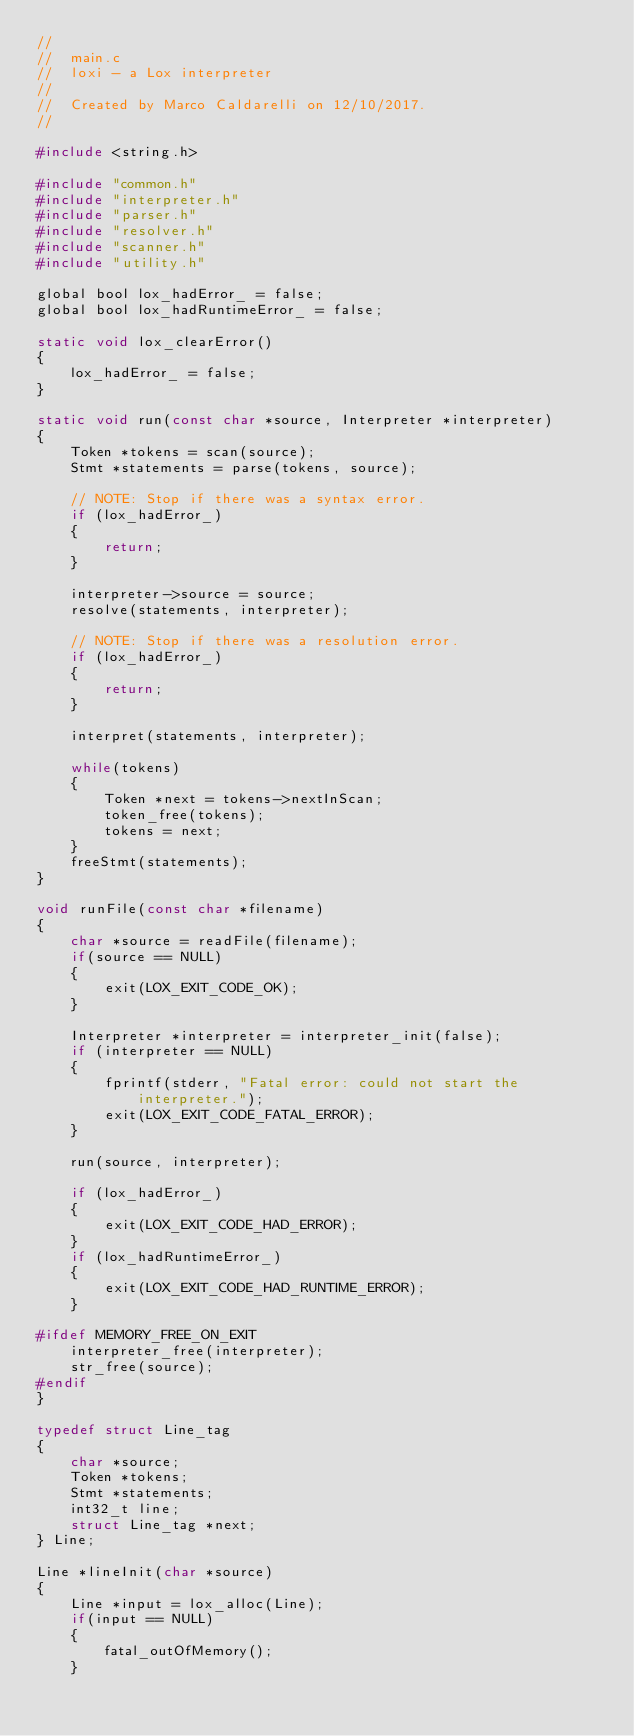<code> <loc_0><loc_0><loc_500><loc_500><_C_>//
//  main.c
//  loxi - a Lox interpreter
//
//  Created by Marco Caldarelli on 12/10/2017.
//

#include <string.h>

#include "common.h"
#include "interpreter.h"
#include "parser.h"
#include "resolver.h"
#include "scanner.h"
#include "utility.h"

global bool lox_hadError_ = false;
global bool lox_hadRuntimeError_ = false;

static void lox_clearError()
{
    lox_hadError_ = false;
}

static void run(const char *source, Interpreter *interpreter)
{
    Token *tokens = scan(source);
    Stmt *statements = parse(tokens, source);
    
    // NOTE: Stop if there was a syntax error.
    if (lox_hadError_)
    {
        return;
    }
    
    interpreter->source = source;
    resolve(statements, interpreter);

    // NOTE: Stop if there was a resolution error.
    if (lox_hadError_)
    {
        return;
    }
    
    interpret(statements, interpreter);

    while(tokens)
    {
        Token *next = tokens->nextInScan;
        token_free(tokens);
        tokens = next;
    }
    freeStmt(statements);
}

void runFile(const char *filename)
{
    char *source = readFile(filename);
    if(source == NULL)
    {
        exit(LOX_EXIT_CODE_OK);
    }
    
    Interpreter *interpreter = interpreter_init(false);
    if (interpreter == NULL)
    {
        fprintf(stderr, "Fatal error: could not start the interpreter.");
        exit(LOX_EXIT_CODE_FATAL_ERROR);
    }

    run(source, interpreter);

    if (lox_hadError_)
    {
        exit(LOX_EXIT_CODE_HAD_ERROR);
    }
    if (lox_hadRuntimeError_)
    {
        exit(LOX_EXIT_CODE_HAD_RUNTIME_ERROR);
    }
    
#ifdef MEMORY_FREE_ON_EXIT
    interpreter_free(interpreter);
    str_free(source);
#endif
}

typedef struct Line_tag
{
    char *source;
    Token *tokens;
    Stmt *statements;
    int32_t line;
    struct Line_tag *next;
} Line;

Line *lineInit(char *source)
{
    Line *input = lox_alloc(Line);
    if(input == NULL)
    {
        fatal_outOfMemory();
    }</code> 